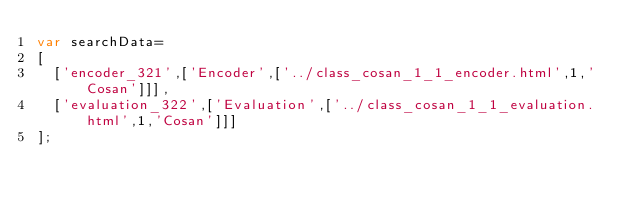Convert code to text. <code><loc_0><loc_0><loc_500><loc_500><_JavaScript_>var searchData=
[
  ['encoder_321',['Encoder',['../class_cosan_1_1_encoder.html',1,'Cosan']]],
  ['evaluation_322',['Evaluation',['../class_cosan_1_1_evaluation.html',1,'Cosan']]]
];
</code> 